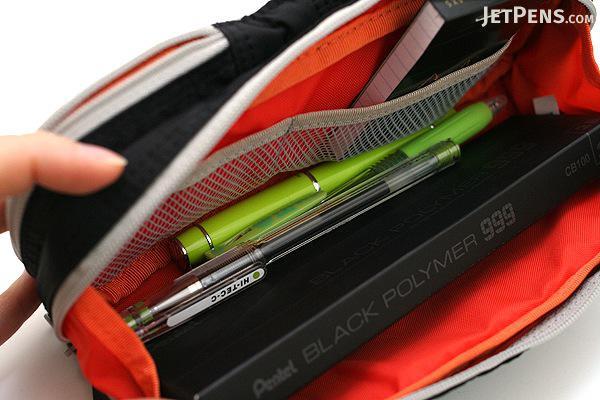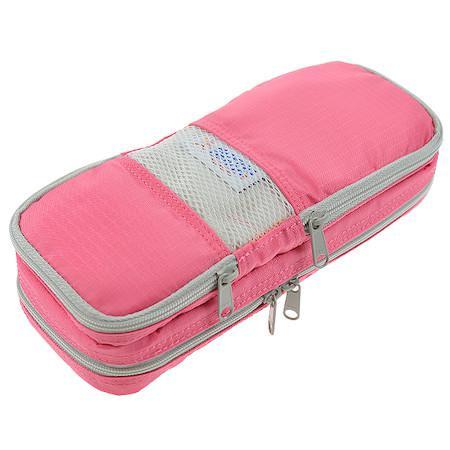The first image is the image on the left, the second image is the image on the right. For the images displayed, is the sentence "There is at least one pink pencil case." factually correct? Answer yes or no. Yes. The first image is the image on the left, the second image is the image on the right. Assess this claim about the two images: "An image shows one soft-sided case that is zipped shut.". Correct or not? Answer yes or no. Yes. 